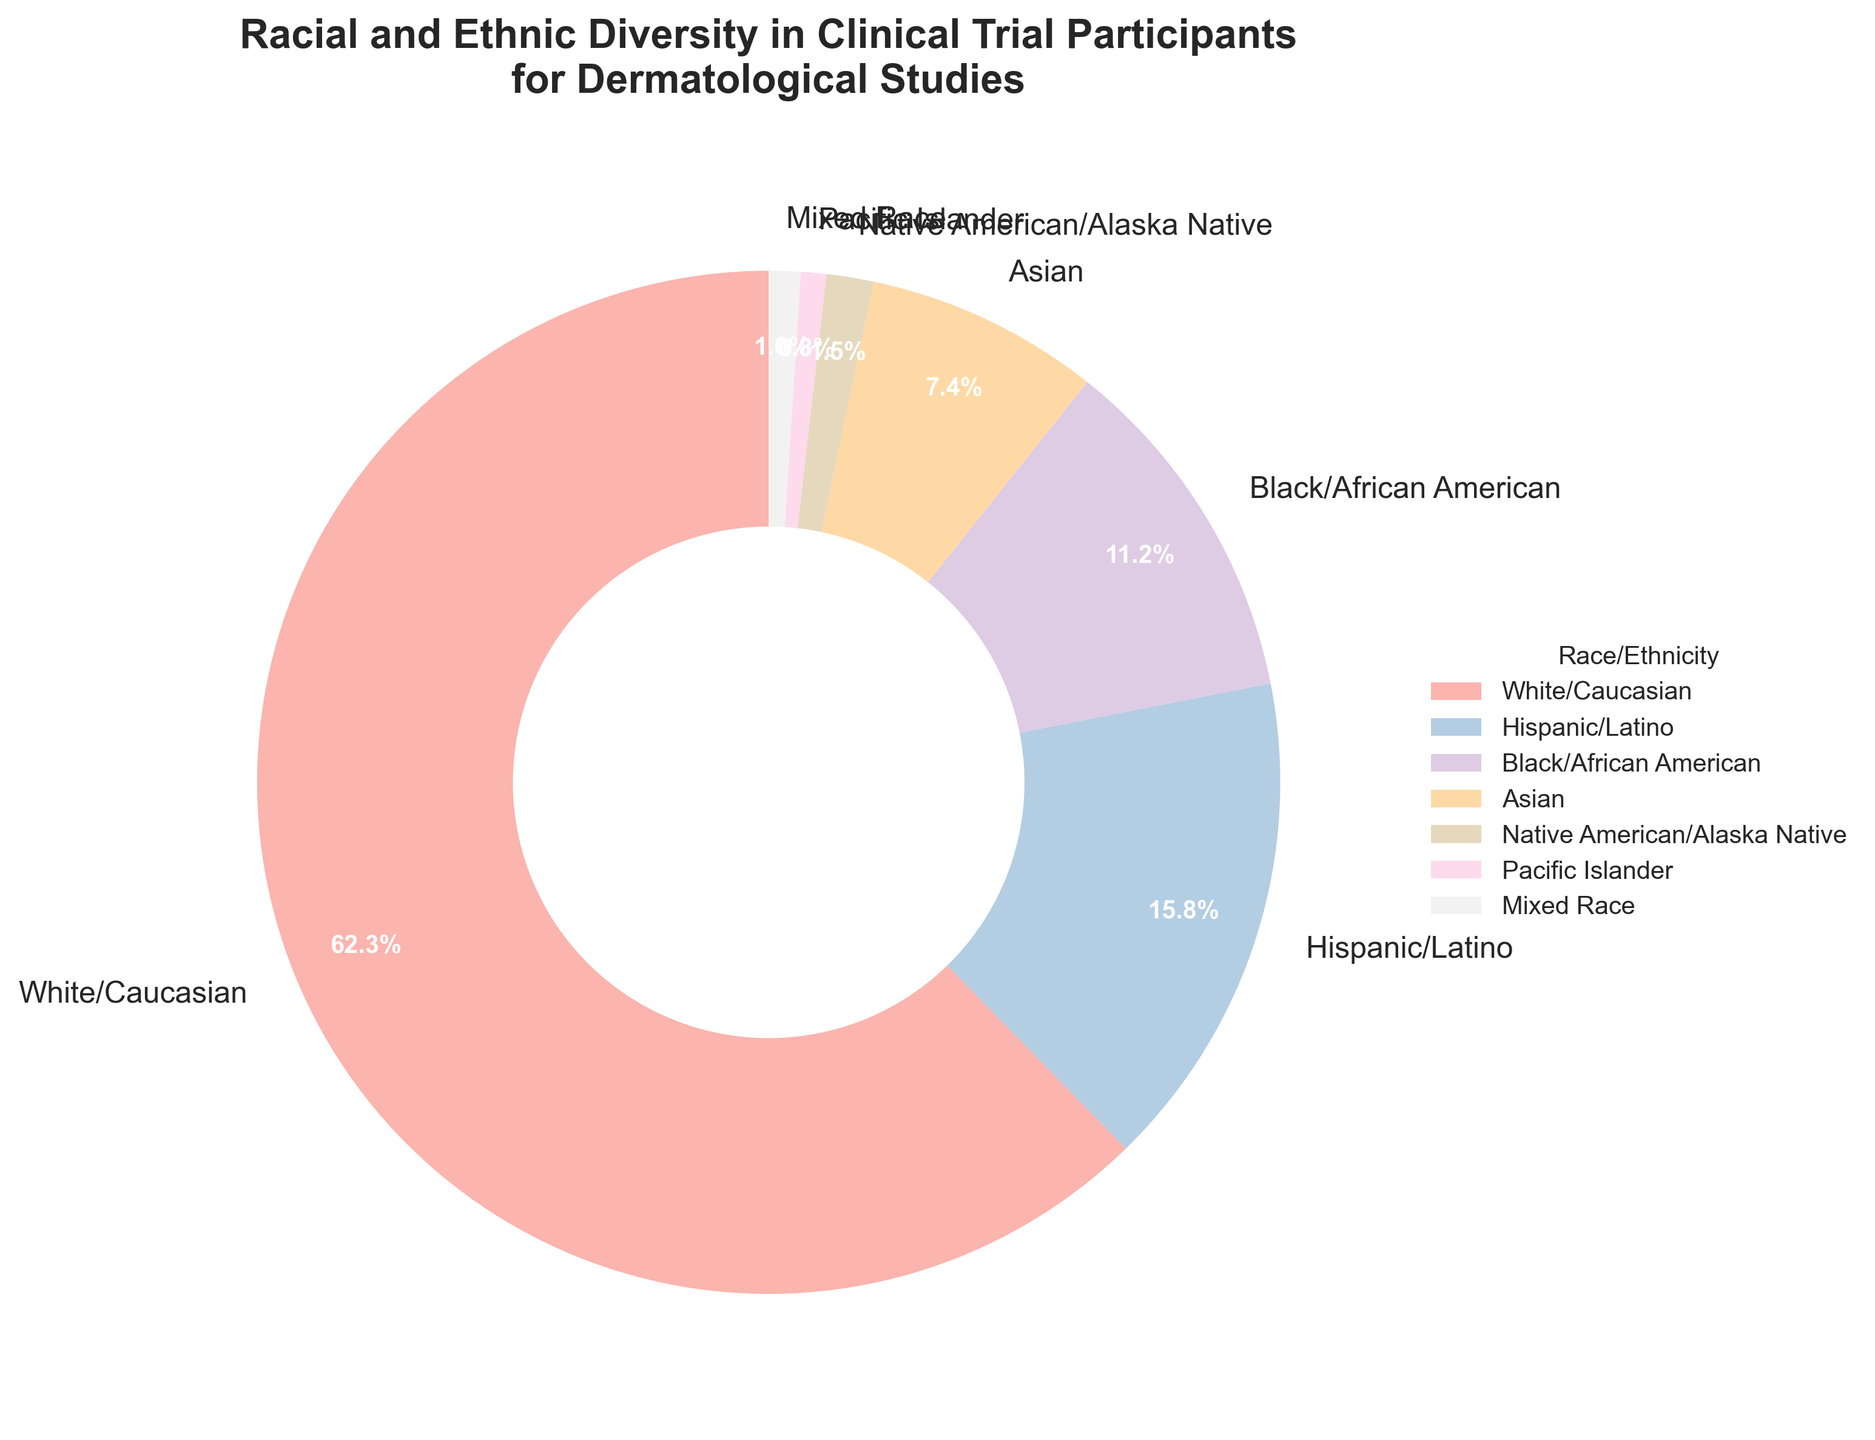Which racial/ethnic group has the highest participation percentage? The pie chart shows that 'White/Caucasian' has the largest segment.
Answer: White/Caucasian Which racial/ethnic group has the lowest participation percentage? The pie chart indicates 'Pacific Islander' has the smallest segment.
Answer: Pacific Islander How much more participation percentage does 'White/Caucasian' have compared to 'Black/African American'? 'White/Caucasian' has 62.3%, and 'Black/African American' has 11.2%. The difference is 62.3 - 11.2 = 51.1%.
Answer: 51.1% What is the combined participation percentage of 'Asian', 'Native American/Alaska Native', and 'Pacific Islander'? Add the percentages: 7.4% (Asian) + 1.5% (Native American/Alaska Native) + 0.8% (Pacific Islander) = 9.7%.
Answer: 9.7% Are there more 'Hispanic/Latino' participants or 'Black/African American' participants? The 'Hispanic/Latino' group has 15.8%, whereas 'Black/African American' has 11.2%. 15.8% > 11.2%.
Answer: Hispanic/Latino What is the difference in participation percentage between 'Asian' and 'Mixed Race'? 'Asian' has 7.4%, and 'Mixed Race' has 1.0%. The difference is 7.4 - 1.0 = 6.4%.
Answer: 6.4% Which racial/ethnic group's segment visually appears closest in size to the 'Mixed Race' group? The 'Pacific Islander' segment visually appears closest to 'Mixed Race' on the pie chart.
Answer: Pacific Islander Is the percentage of 'Hispanic/Latino' participants less than or greater than one-fourth of the total participants? One-fourth of the total is 25%. The 'Hispanic/Latino' percentage is 15.8%, which is less than 25%.
Answer: Less How much more of the total percentage do 'White/Caucasian', 'Hispanic/Latino', and 'Black/African American' groups account for compared to the remaining groups combined? The total of 'White/Caucasian', 'Hispanic/Latino', and 'Black/African American' is 62.3 + 15.8 + 11.2 = 89.3%. The remaining groups' total is 7.4 (Asian) + 1.5 (Native American/Alaska Native) + 0.8 (Pacific Islander) + 1.0 (Mixed Race) = 10.7%. The difference is 89.3% - 10.7% = 78.6%.
Answer: 78.6% 